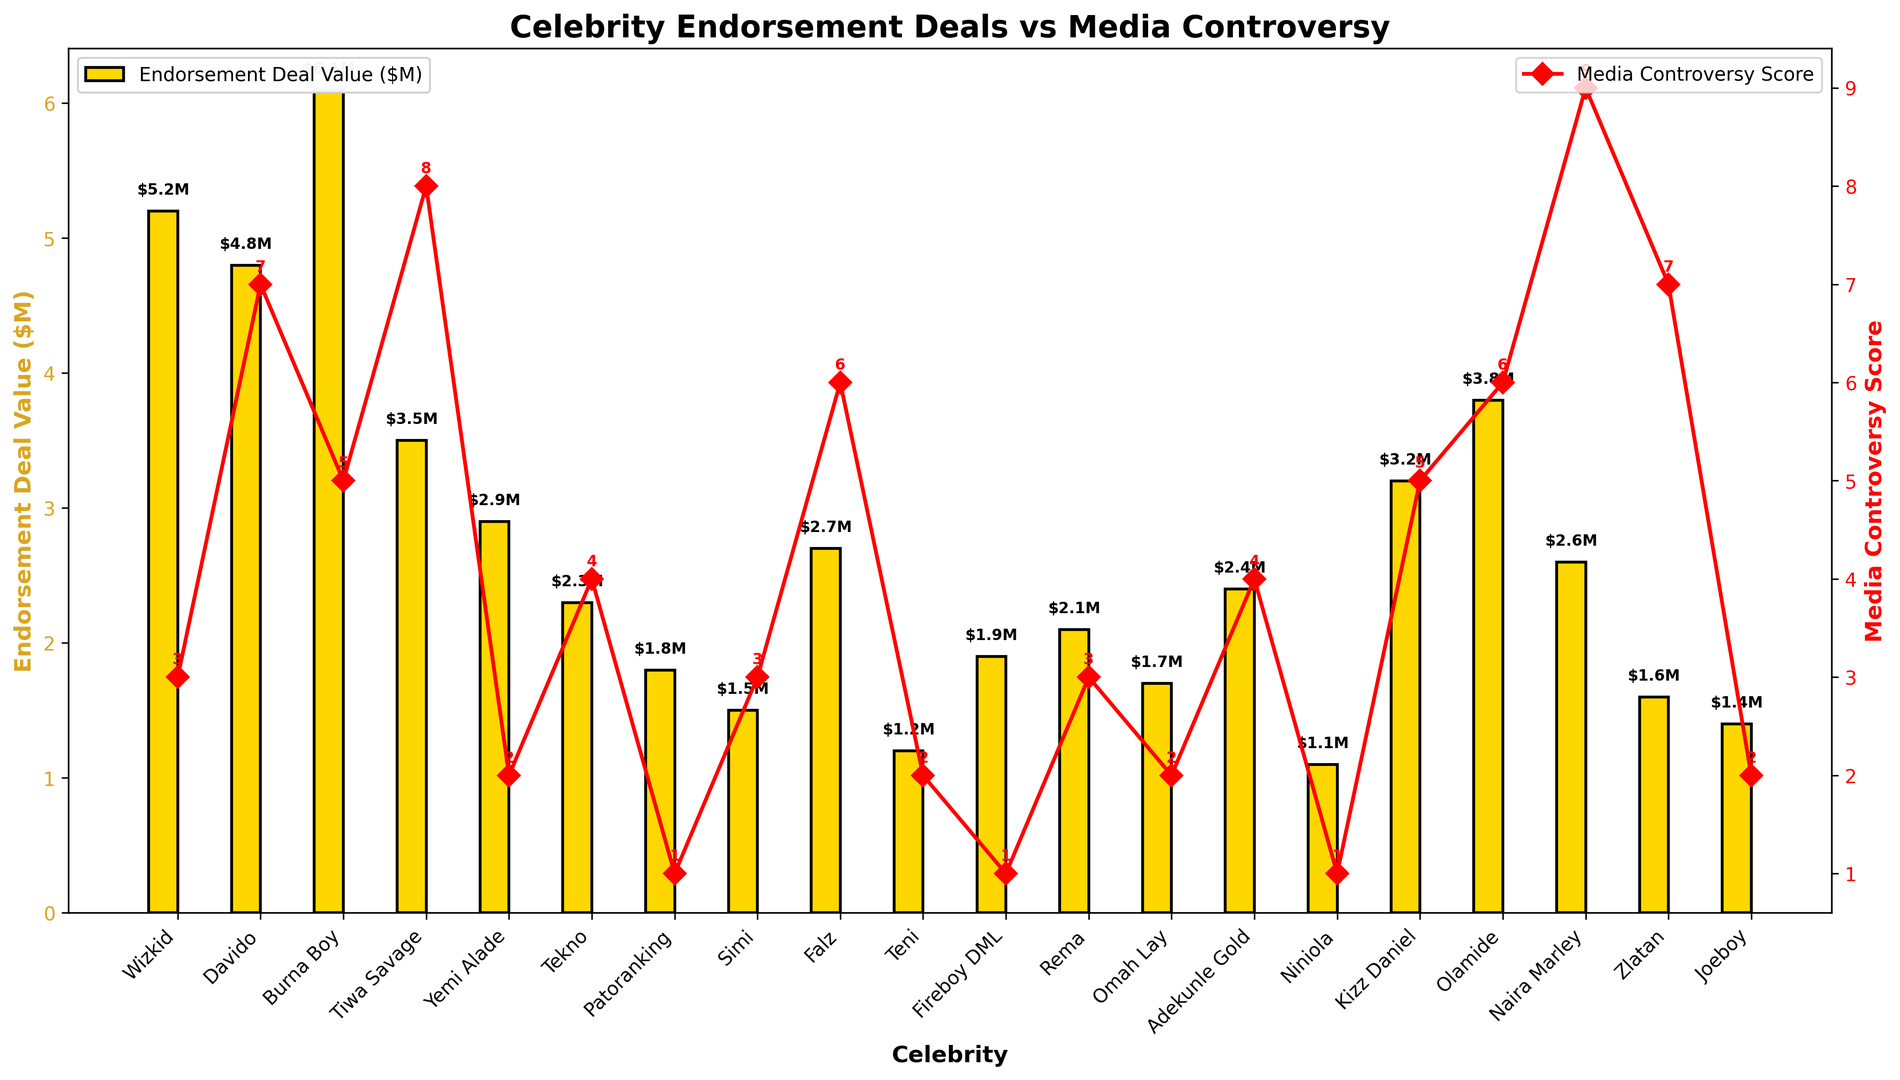What's the total endorsement deal value for Davido and Burna Boy combined? To find the total endorsement deal value for Davido and Burna Boy, add their individual deal values together. Davido's deal value is $4.8M, and Burna Boy's deal value is $6.1M. So, $4.8M + $6.1M = $10.9M
Answer: $10.9M Which celebrity has the highest media controversy score? To find the celebrity with the highest media controversy score, look at the red line plot and identify the point with the highest value. The highest media controversy score is 9, and it belongs to Naira Marley
Answer: Naira Marley Compare the endorsement deal values of Yemi Alade and Tekno. Which one is higher? Yemi Alade's endorsement deal value is $2.9M, while Tekno's endorsement deal value is $2.3M. Comparing these values, Yemi Alade's deal is higher
Answer: Yemi Alade What's the average endorsement deal value of celebrities with a media controversy score of less than 5? Identify celebrities with a media controversy score of less than 5: Wizkid, Yemi Alade, Patoranking, Simi, Teni, Fireboy DML, Omah Lay, Niniola, and Joeboy. Sum their endorsement values: $5.2M + $2.9M + $1.8M + $1.5M + $1.2M + $1.9M + $1.7M + $1.1M + $1.4M = $18.7M. There are 9 celebrities, so the average is $18.7M/9 ≈ $2.08M
Answer: $2.08M Which celebrity has the lowest endorsement deal value, and what is it? To find the celebrity with the lowest endorsement deal value, look at the height of the gold bars. The shortest bar corresponds to Niniola with an endorsement deal value of $1.1M
Answer: Niniola, $1.1M What is the difference in media controversy score between Tiwa Savage and Falz? Tiwa Savage's media controversy score is 8, and Falz's score is 6. The difference is calculated as 8 - 6 = 2
Answer: 2 Which celebrity with a media controversy score of 3 has the highest endorsement deal value? Celebrities with a media controversy score of 3 are Wizkid, Simi, and Rema. Their endorsement deal values are $5.2M (Wizkid), $1.5M (Simi), and $2.1M (Rema). The highest value among these is $5.2M, belonging to Wizkid
Answer: Wizkid Is there any celebrity whose endorsement deal value is below $2M but has a media controversy score of 5 or more? Check the bars for endorsement deal values below $2M and correlate them with media controversy scores of 5 or more. Zlatan has an endorsement deal value of $1.6M and a media controversy score of 7
Answer: Zlatan How does Olamide's endorsement deal value compare to that of Tiwa Savage? Olamide's endorsement deal value is $3.8M, and Tiwa Savage's value is $3.5M. Olamide's endorsement deal value is higher by $0.3M
Answer: Olamide What's the median media controversy score for all celebrities? Order the media controversy scores: 1, 1, 1, 2, 2, 2, 2, 3, 3, 3, 4, 4, 5, 5, 6, 6, 7, 7, 8, 9. The median value is the 10th and 11th scores averaged (3 and 4), so (3+4)/2 = 3.5
Answer: 3.5 